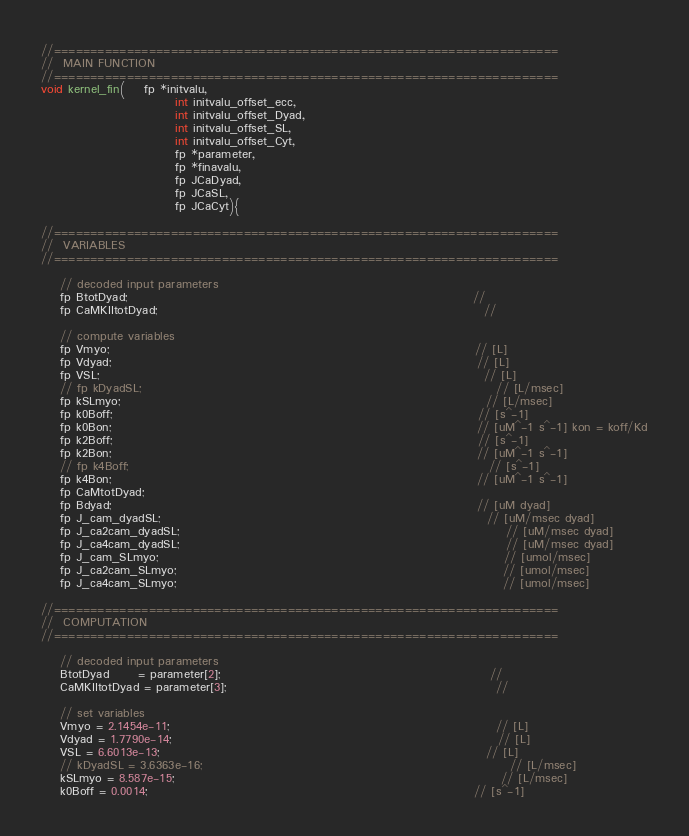Convert code to text. <code><loc_0><loc_0><loc_500><loc_500><_Cuda_>//=====================================================================
//	MAIN FUNCTION
//=====================================================================
void kernel_fin(	fp *initvalu,
							int initvalu_offset_ecc,
							int initvalu_offset_Dyad,
							int initvalu_offset_SL,
							int initvalu_offset_Cyt,
							fp *parameter,
							fp *finavalu,
							fp JCaDyad,
							fp JCaSL,
							fp JCaCyt){

//=====================================================================
//	VARIABLES
//=====================================================================

	// decoded input parameters
	fp BtotDyad;																		//
	fp CaMKIItotDyad;																	//

	// compute variables
	fp Vmyo;																			// [L]
	fp Vdyad;																			// [L]
	fp VSL;																				// [L]
	// fp kDyadSL;																			// [L/msec]
	fp kSLmyo;																			// [L/msec]
	fp k0Boff;																			// [s^-1] 
	fp k0Bon;																			// [uM^-1 s^-1] kon = koff/Kd
	fp k2Boff;																			// [s^-1] 
	fp k2Bon;																			// [uM^-1 s^-1]
	// fp k4Boff;																			// [s^-1]
	fp k4Bon;																			// [uM^-1 s^-1]
	fp CaMtotDyad;
	fp Bdyad;																			// [uM dyad]
	fp J_cam_dyadSL;																	// [uM/msec dyad]
	fp J_ca2cam_dyadSL;																	// [uM/msec dyad]
	fp J_ca4cam_dyadSL;																	// [uM/msec dyad]
	fp J_cam_SLmyo;																		// [umol/msec]
	fp J_ca2cam_SLmyo;																	// [umol/msec]
	fp J_ca4cam_SLmyo;																	// [umol/msec]

//=====================================================================
//	COMPUTATION
//=====================================================================

	// decoded input parameters
	BtotDyad      = parameter[2];														//
	CaMKIItotDyad = parameter[3];														//

	// set variables
	Vmyo = 2.1454e-11;																	// [L]
	Vdyad = 1.7790e-14;																	// [L]
	VSL = 6.6013e-13;																	// [L]
	// kDyadSL = 3.6363e-16;																// [L/msec]
	kSLmyo = 8.587e-15;																	// [L/msec]
	k0Boff = 0.0014;																	// [s^-1] </code> 